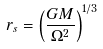Convert formula to latex. <formula><loc_0><loc_0><loc_500><loc_500>r _ { s } = \left ( \frac { G M } { \Omega ^ { 2 } } \right ) ^ { 1 / 3 }</formula> 